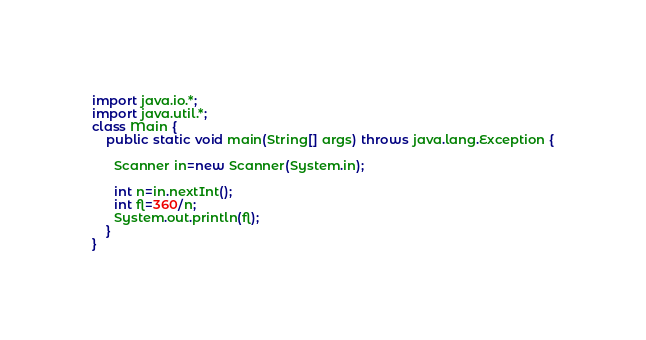<code> <loc_0><loc_0><loc_500><loc_500><_Java_>import java.io.*;
import java.util.*;
class Main {
    public static void main(String[] args) throws java.lang.Exception {
      
      Scanner in=new Scanner(System.in);
      
      int n=in.nextInt();
      int fl=360/n;
      System.out.println(fl);
    }
}</code> 